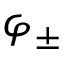Convert formula to latex. <formula><loc_0><loc_0><loc_500><loc_500>\varphi _ { \pm }</formula> 